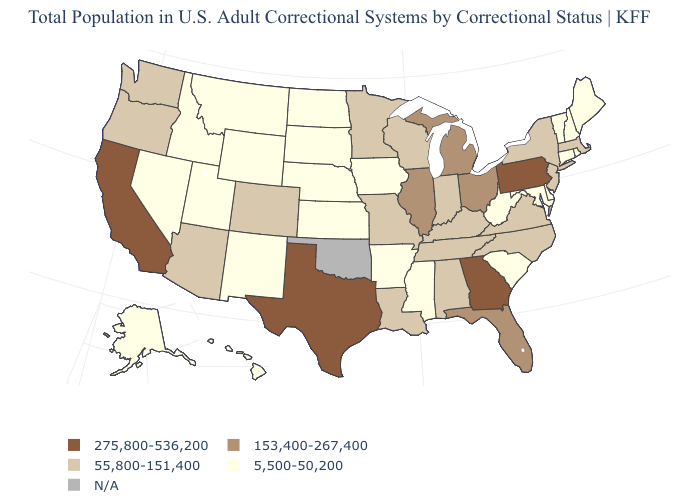Does the first symbol in the legend represent the smallest category?
Give a very brief answer. No. Is the legend a continuous bar?
Concise answer only. No. Name the states that have a value in the range 5,500-50,200?
Answer briefly. Alaska, Arkansas, Connecticut, Delaware, Hawaii, Idaho, Iowa, Kansas, Maine, Maryland, Mississippi, Montana, Nebraska, Nevada, New Hampshire, New Mexico, North Dakota, Rhode Island, South Carolina, South Dakota, Utah, Vermont, West Virginia, Wyoming. Name the states that have a value in the range 275,800-536,200?
Give a very brief answer. California, Georgia, Pennsylvania, Texas. Does the map have missing data?
Short answer required. Yes. What is the value of New York?
Give a very brief answer. 55,800-151,400. Name the states that have a value in the range 5,500-50,200?
Answer briefly. Alaska, Arkansas, Connecticut, Delaware, Hawaii, Idaho, Iowa, Kansas, Maine, Maryland, Mississippi, Montana, Nebraska, Nevada, New Hampshire, New Mexico, North Dakota, Rhode Island, South Carolina, South Dakota, Utah, Vermont, West Virginia, Wyoming. What is the value of Massachusetts?
Be succinct. 55,800-151,400. What is the highest value in the USA?
Answer briefly. 275,800-536,200. Does the map have missing data?
Short answer required. Yes. Among the states that border New Hampshire , does Massachusetts have the highest value?
Keep it brief. Yes. What is the value of Connecticut?
Keep it brief. 5,500-50,200. Does the map have missing data?
Answer briefly. Yes. 